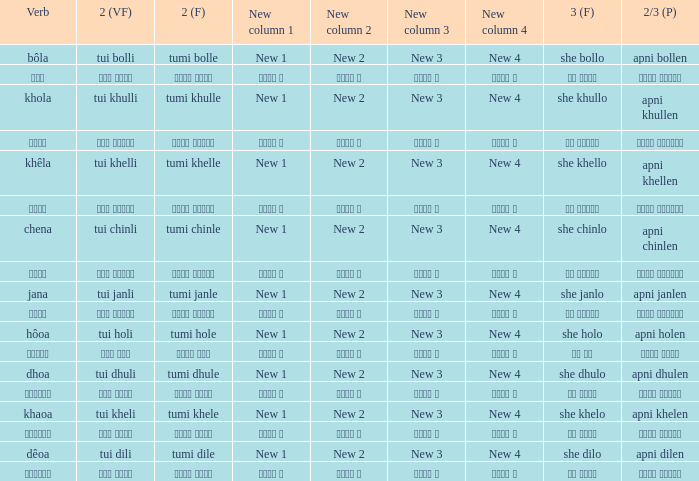Write the full table. {'header': ['Verb', '2 (VF)', '2 (F)', 'New column 1', 'New column 2', 'New column 3', 'New column 4', '3 (F)', '2/3 (P)'], 'rows': [['bôla', 'tui bolli', 'tumi bolle', 'New 1', 'New 2', 'New 3', 'New 4', 'she bollo', 'apni bollen'], ['বলা', 'তুই বললি', 'তুমি বললে', 'নতুন ১', 'নতুন ২', 'নতুন ৩', 'নতুন ৪', 'সে বললো', 'আপনি বললেন'], ['khola', 'tui khulli', 'tumi khulle', 'New 1', 'New 2', 'New 3', 'New 4', 'she khullo', 'apni khullen'], ['খোলা', 'তুই খুললি', 'তুমি খুললে', 'নতুন ১', 'নতুন ২', 'নতুন ৩', 'নতুন ৪', 'সে খুললো', 'আপনি খুললেন'], ['khêla', 'tui khelli', 'tumi khelle', 'New 1', 'New 2', 'New 3', 'New 4', 'she khello', 'apni khellen'], ['খেলে', 'তুই খেললি', 'তুমি খেললে', 'নতুন ১', 'নতুন ২', 'নতুন ৩', 'নতুন ৪', 'সে খেললো', 'আপনি খেললেন'], ['chena', 'tui chinli', 'tumi chinle', 'New 1', 'New 2', 'New 3', 'New 4', 'she chinlo', 'apni chinlen'], ['চেনা', 'তুই চিনলি', 'তুমি চিনলে', 'নতুন ১', 'নতুন ২', 'নতুন ৩', 'নতুন ৪', 'সে চিনলো', 'আপনি চিনলেন'], ['jana', 'tui janli', 'tumi janle', 'New 1', 'New 2', 'New 3', 'New 4', 'she janlo', 'apni janlen'], ['জানা', 'তুই জানলি', 'তুমি জানলে', 'নতুন ১', 'নতুন ২', 'নতুন ৩', 'নতুন ৪', 'সে জানলে', 'আপনি জানলেন'], ['hôoa', 'tui holi', 'tumi hole', 'New 1', 'New 2', 'New 3', 'New 4', 'she holo', 'apni holen'], ['হওয়া', 'তুই হলি', 'তুমি হলে', 'নতুন ১', 'নতুন ২', 'নতুন ৩', 'নতুন ৪', 'সে হল', 'আপনি হলেন'], ['dhoa', 'tui dhuli', 'tumi dhule', 'New 1', 'New 2', 'New 3', 'New 4', 'she dhulo', 'apni dhulen'], ['ধোওয়া', 'তুই ধুলি', 'তুমি ধুলে', 'নতুন ১', 'নতুন ২', 'নতুন ৩', 'নতুন ৪', 'সে ধুলো', 'আপনি ধুলেন'], ['khaoa', 'tui kheli', 'tumi khele', 'New 1', 'New 2', 'New 3', 'New 4', 'she khelo', 'apni khelen'], ['খাওয়া', 'তুই খেলি', 'তুমি খেলে', 'নতুন ১', 'নতুন ২', 'নতুন ৩', 'নতুন ৪', 'সে খেলো', 'আপনি খেলেন'], ['dêoa', 'tui dili', 'tumi dile', 'New 1', 'New 2', 'New 3', 'New 4', 'she dilo', 'apni dilen'], ['দেওয়া', 'তুই দিলি', 'তুমি দিলে', 'নতুন ১', 'নতুন ২', 'নতুন ৩', 'নতুন ৪', 'সে দিলো', 'আপনি দিলেন']]} What is the 3rd for the 2nd Tui Dhuli? She dhulo. 